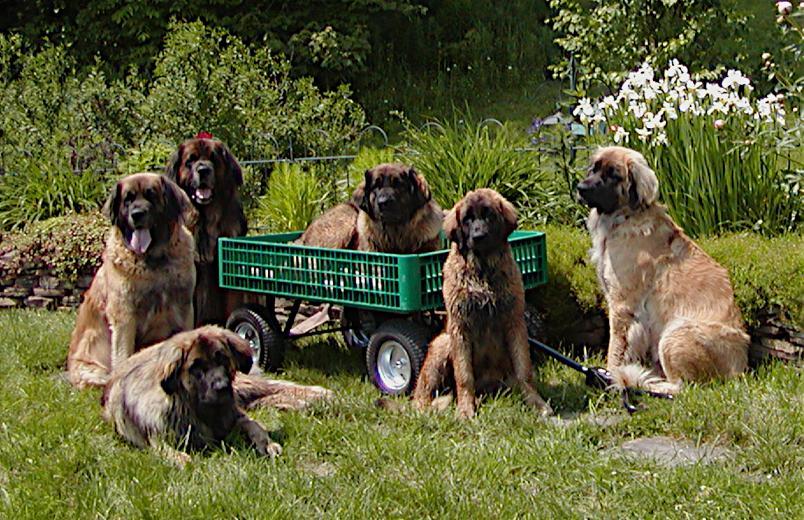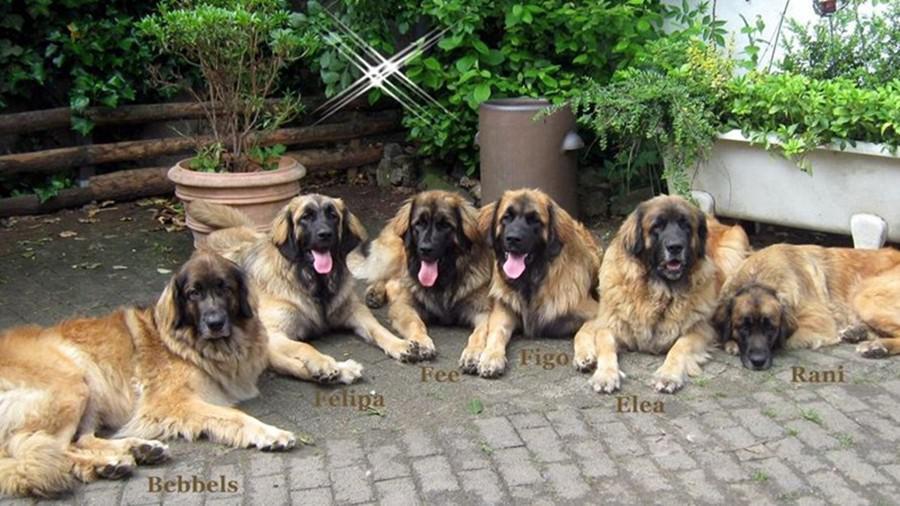The first image is the image on the left, the second image is the image on the right. Considering the images on both sides, is "A group of dogs is in the grass in at least one picture." valid? Answer yes or no. Yes. The first image is the image on the left, the second image is the image on the right. For the images shown, is this caption "None of the dogs are alone and at least one of the dogs has a dark colored face." true? Answer yes or no. Yes. 